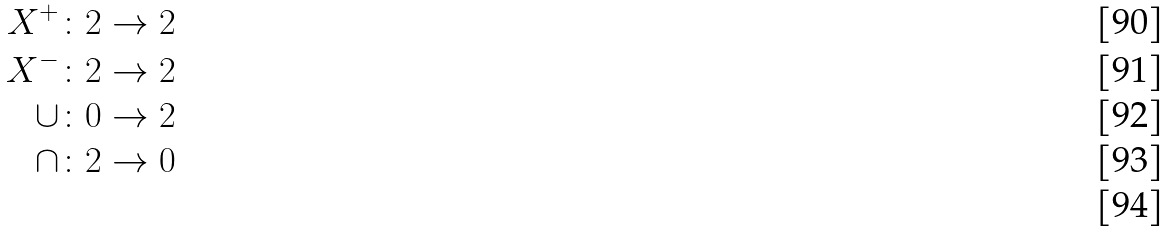Convert formula to latex. <formula><loc_0><loc_0><loc_500><loc_500>X ^ { + } \colon & 2 \rightarrow 2 \\ X ^ { - } \colon & 2 \rightarrow 2 \\ \cup \colon & 0 \rightarrow 2 \\ \cap \colon & 2 \rightarrow 0 \\</formula> 